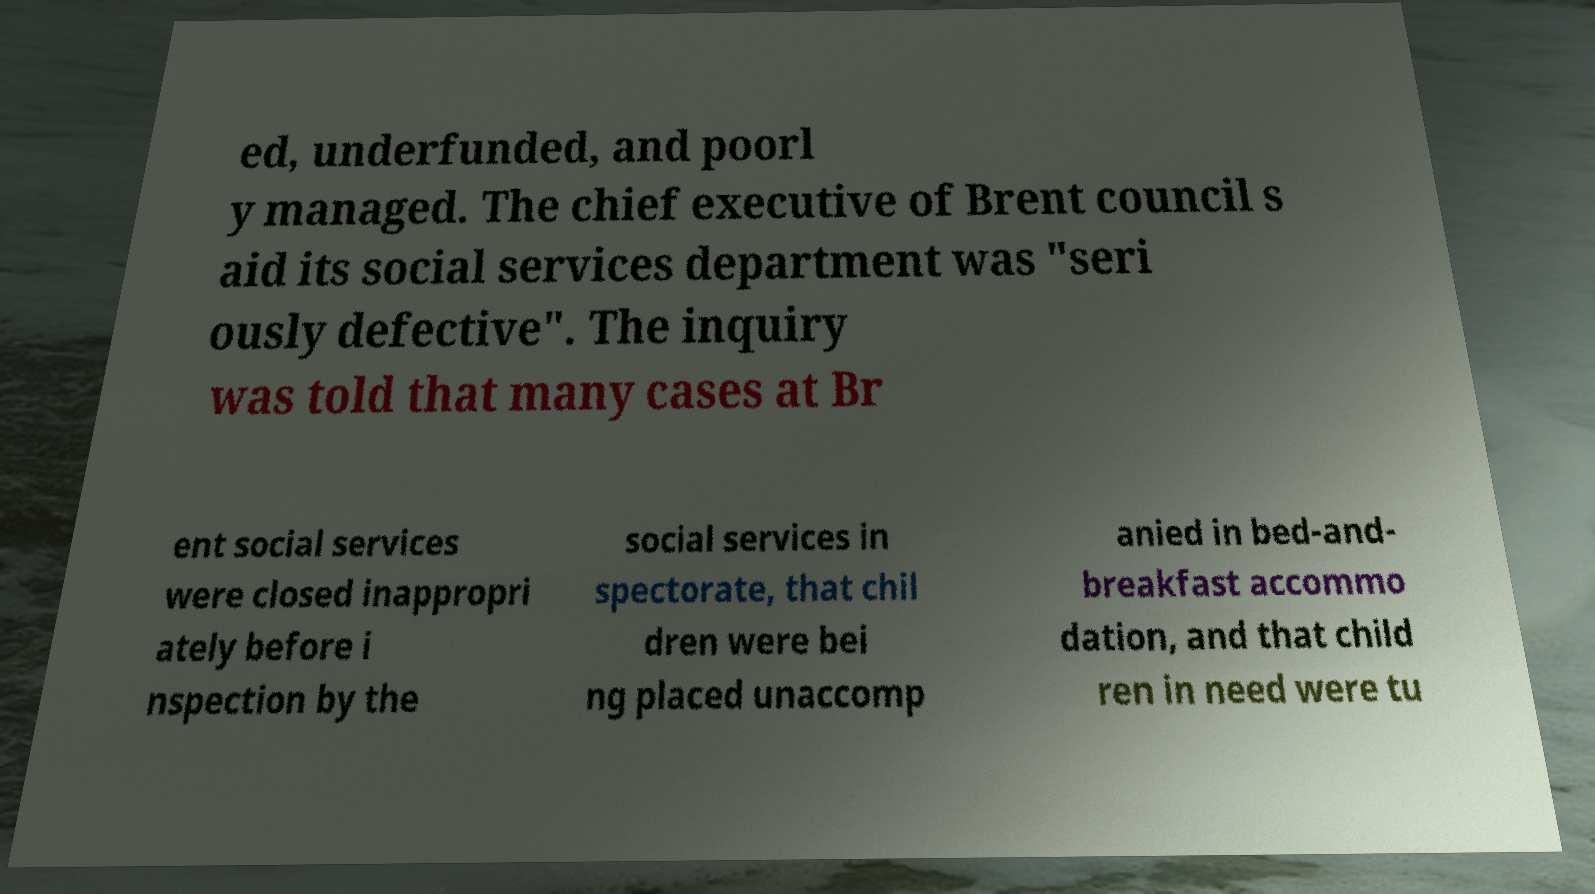Please read and relay the text visible in this image. What does it say? ed, underfunded, and poorl y managed. The chief executive of Brent council s aid its social services department was "seri ously defective". The inquiry was told that many cases at Br ent social services were closed inappropri ately before i nspection by the social services in spectorate, that chil dren were bei ng placed unaccomp anied in bed-and- breakfast accommo dation, and that child ren in need were tu 